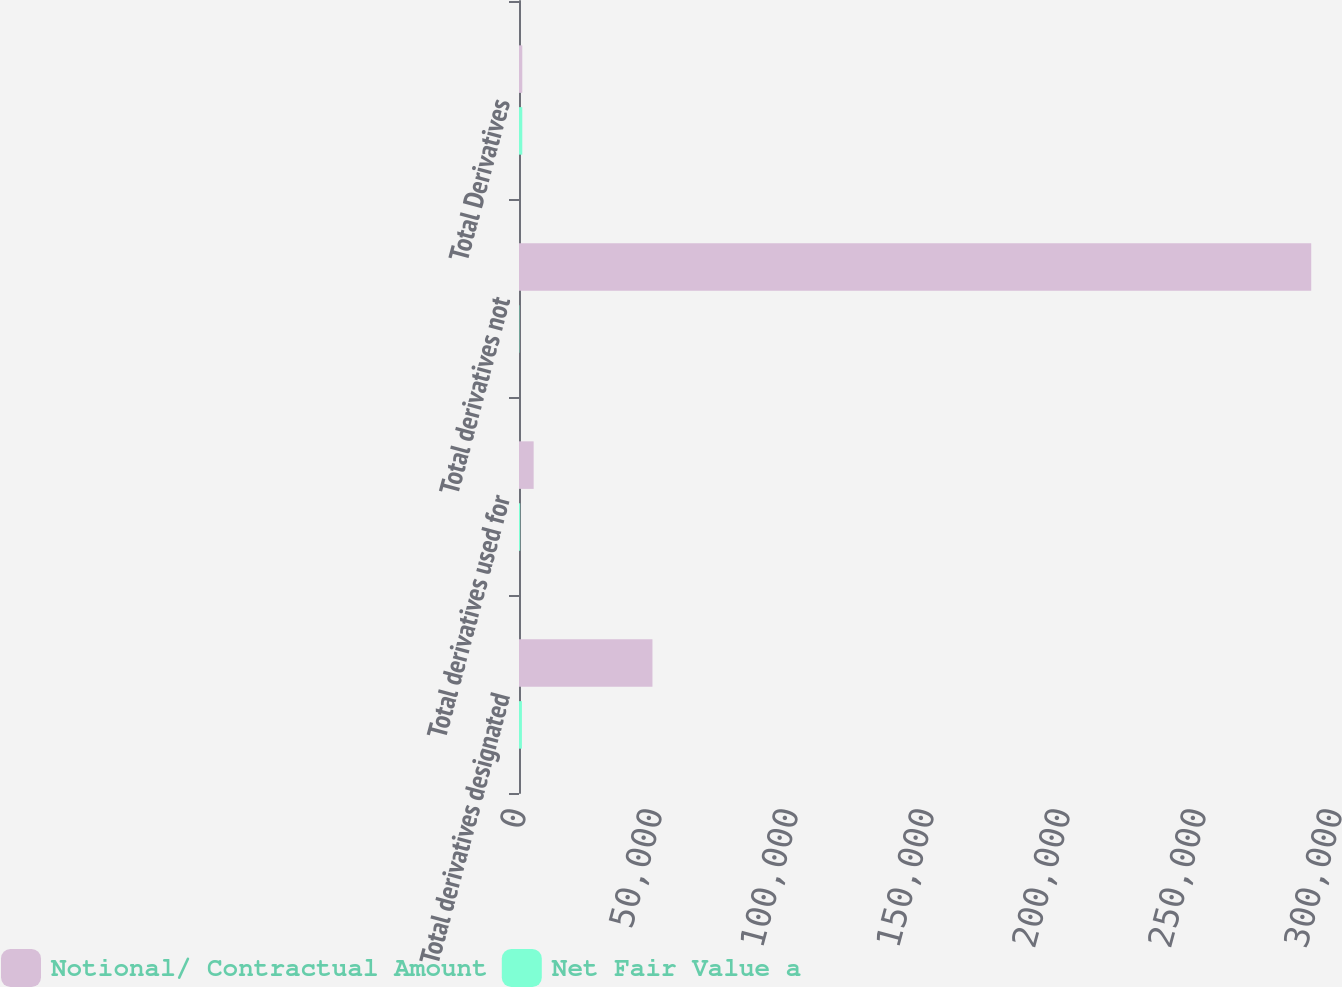Convert chart to OTSL. <chart><loc_0><loc_0><loc_500><loc_500><stacked_bar_chart><ecel><fcel>Total derivatives designated<fcel>Total derivatives used for<fcel>Total derivatives not<fcel>Total Derivatives<nl><fcel>Notional/ Contractual Amount<fcel>49061<fcel>5390<fcel>291256<fcel>1207<nl><fcel>Net Fair Value a<fcel>1075<fcel>425<fcel>132<fcel>1207<nl></chart> 